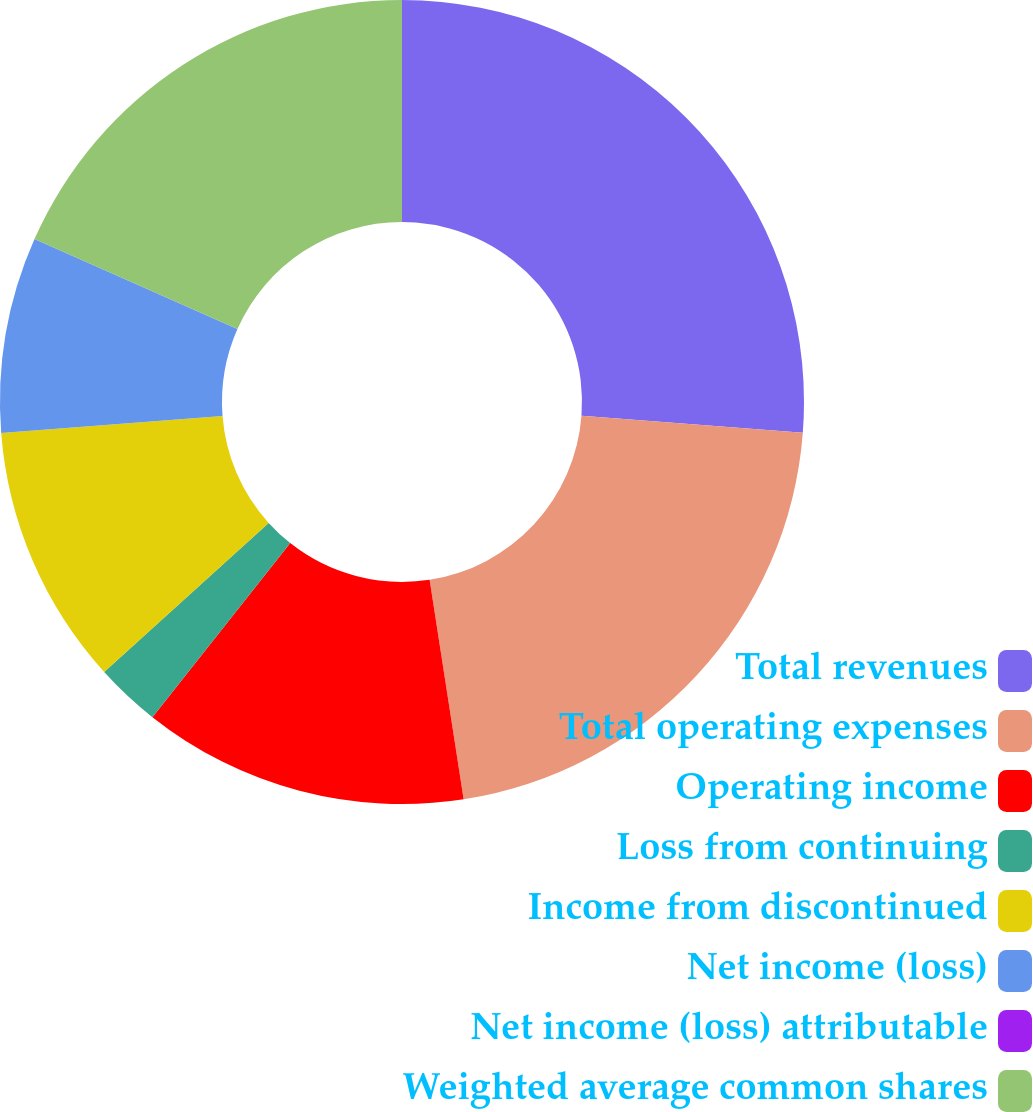Convert chart. <chart><loc_0><loc_0><loc_500><loc_500><pie_chart><fcel>Total revenues<fcel>Total operating expenses<fcel>Operating income<fcel>Loss from continuing<fcel>Income from discontinued<fcel>Net income (loss)<fcel>Net income (loss) attributable<fcel>Weighted average common shares<nl><fcel>26.22%<fcel>21.33%<fcel>13.11%<fcel>2.62%<fcel>10.49%<fcel>7.87%<fcel>0.0%<fcel>18.36%<nl></chart> 